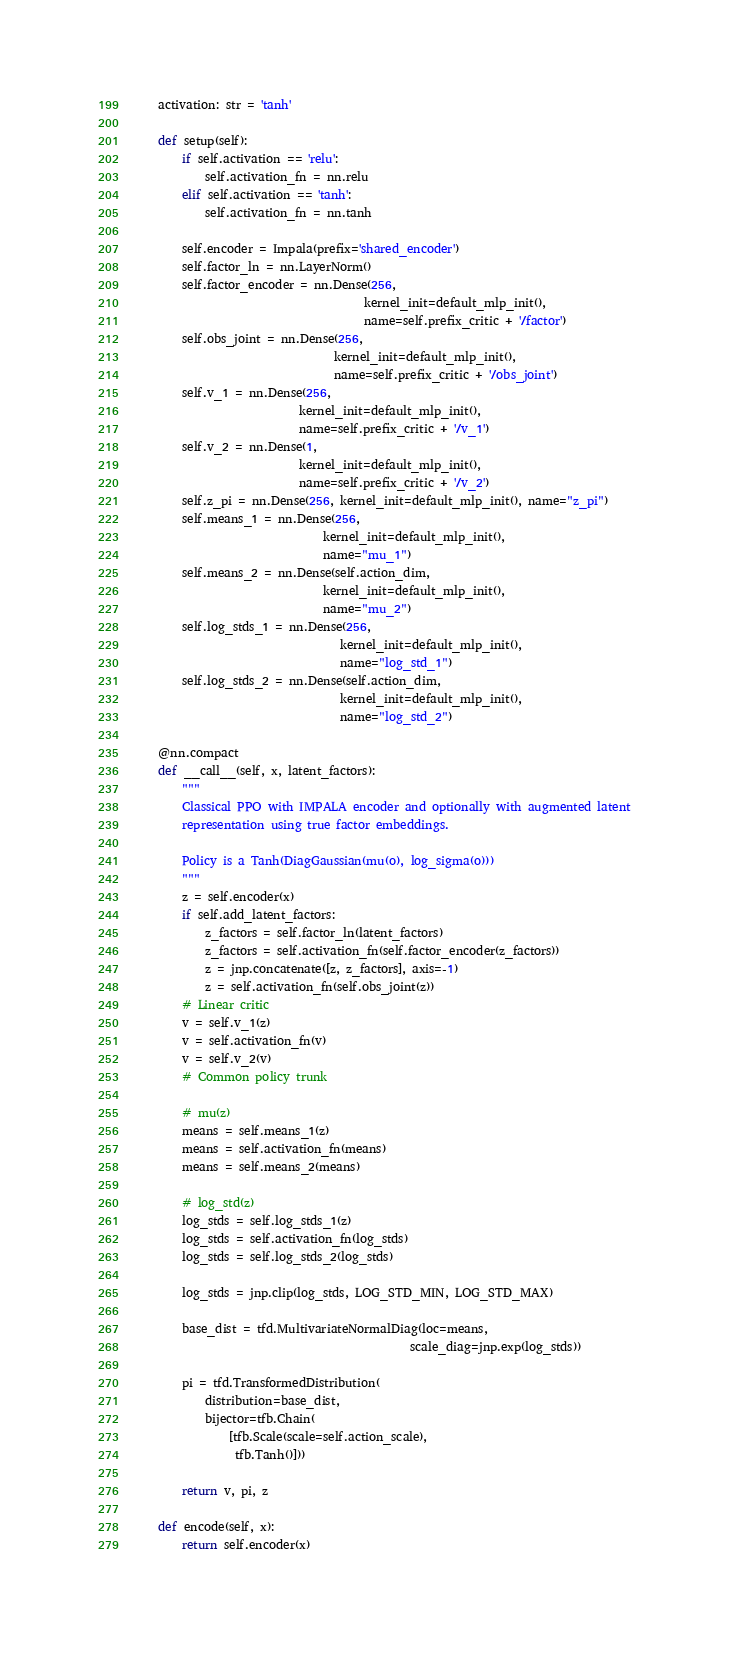Convert code to text. <code><loc_0><loc_0><loc_500><loc_500><_Python_>    activation: str = 'tanh'

    def setup(self):
        if self.activation == 'relu':
            self.activation_fn = nn.relu
        elif self.activation == 'tanh':
            self.activation_fn = nn.tanh

        self.encoder = Impala(prefix='shared_encoder')
        self.factor_ln = nn.LayerNorm()
        self.factor_encoder = nn.Dense(256,
                                       kernel_init=default_mlp_init(),
                                       name=self.prefix_critic + '/factor')
        self.obs_joint = nn.Dense(256,
                                  kernel_init=default_mlp_init(),
                                  name=self.prefix_critic + '/obs_joint')
        self.v_1 = nn.Dense(256,
                            kernel_init=default_mlp_init(),
                            name=self.prefix_critic + '/v_1')
        self.v_2 = nn.Dense(1,
                            kernel_init=default_mlp_init(),
                            name=self.prefix_critic + '/v_2')
        self.z_pi = nn.Dense(256, kernel_init=default_mlp_init(), name="z_pi")
        self.means_1 = nn.Dense(256,
                                kernel_init=default_mlp_init(),
                                name="mu_1")
        self.means_2 = nn.Dense(self.action_dim,
                                kernel_init=default_mlp_init(),
                                name="mu_2")
        self.log_stds_1 = nn.Dense(256,
                                   kernel_init=default_mlp_init(),
                                   name="log_std_1")
        self.log_stds_2 = nn.Dense(self.action_dim,
                                   kernel_init=default_mlp_init(),
                                   name="log_std_2")

    @nn.compact
    def __call__(self, x, latent_factors):
        """
        Classical PPO with IMPALA encoder and optionally with augmented latent
        representation using true factor embeddings.

        Policy is a Tanh(DiagGaussian(mu(o), log_sigma(o)))
        """
        z = self.encoder(x)
        if self.add_latent_factors:
            z_factors = self.factor_ln(latent_factors)
            z_factors = self.activation_fn(self.factor_encoder(z_factors))
            z = jnp.concatenate([z, z_factors], axis=-1)
            z = self.activation_fn(self.obs_joint(z))
        # Linear critic
        v = self.v_1(z)
        v = self.activation_fn(v)
        v = self.v_2(v)
        # Common policy trunk

        # mu(z)
        means = self.means_1(z)
        means = self.activation_fn(means)
        means = self.means_2(means)

        # log_std(z)
        log_stds = self.log_stds_1(z)
        log_stds = self.activation_fn(log_stds)
        log_stds = self.log_stds_2(log_stds)

        log_stds = jnp.clip(log_stds, LOG_STD_MIN, LOG_STD_MAX)

        base_dist = tfd.MultivariateNormalDiag(loc=means,
                                               scale_diag=jnp.exp(log_stds))

        pi = tfd.TransformedDistribution(
            distribution=base_dist,
            bijector=tfb.Chain(
                [tfb.Scale(scale=self.action_scale),
                 tfb.Tanh()]))

        return v, pi, z

    def encode(self, x):
        return self.encoder(x)
</code> 